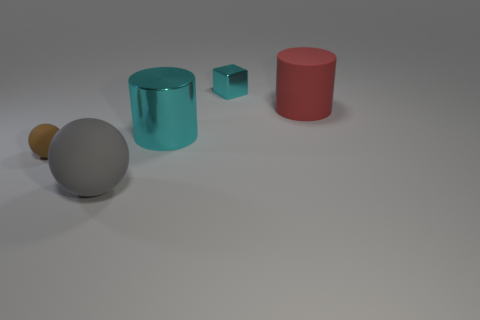The metallic cylinder that is the same color as the small metallic block is what size?
Offer a very short reply. Large. There is a big rubber object behind the large gray sphere; is it the same shape as the big matte thing that is in front of the big red rubber object?
Your answer should be very brief. No. There is a brown matte ball; how many tiny cyan metal blocks are to the right of it?
Offer a terse response. 1. Does the ball that is on the right side of the small brown rubber sphere have the same material as the large cyan object?
Your response must be concise. No. There is a tiny matte thing that is the same shape as the large gray thing; what is its color?
Your answer should be compact. Brown. There is a large gray rubber object; what shape is it?
Give a very brief answer. Sphere. What number of objects are rubber objects or big cyan metal objects?
Your response must be concise. 4. There is a metallic object in front of the small cyan metal block; is its color the same as the object behind the rubber cylinder?
Provide a short and direct response. Yes. What number of other things are the same shape as the tiny brown thing?
Offer a very short reply. 1. Is there a brown metal sphere?
Your response must be concise. No. 